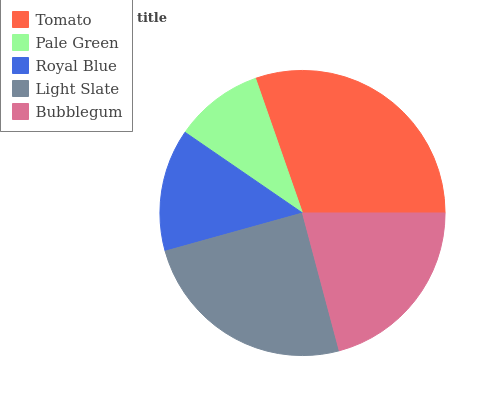Is Pale Green the minimum?
Answer yes or no. Yes. Is Tomato the maximum?
Answer yes or no. Yes. Is Royal Blue the minimum?
Answer yes or no. No. Is Royal Blue the maximum?
Answer yes or no. No. Is Royal Blue greater than Pale Green?
Answer yes or no. Yes. Is Pale Green less than Royal Blue?
Answer yes or no. Yes. Is Pale Green greater than Royal Blue?
Answer yes or no. No. Is Royal Blue less than Pale Green?
Answer yes or no. No. Is Bubblegum the high median?
Answer yes or no. Yes. Is Bubblegum the low median?
Answer yes or no. Yes. Is Royal Blue the high median?
Answer yes or no. No. Is Pale Green the low median?
Answer yes or no. No. 